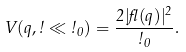Convert formula to latex. <formula><loc_0><loc_0><loc_500><loc_500>V ( q , \omega \ll \omega _ { 0 } ) = \frac { 2 | \gamma ( q ) | ^ { 2 } } { \omega _ { 0 } } .</formula> 